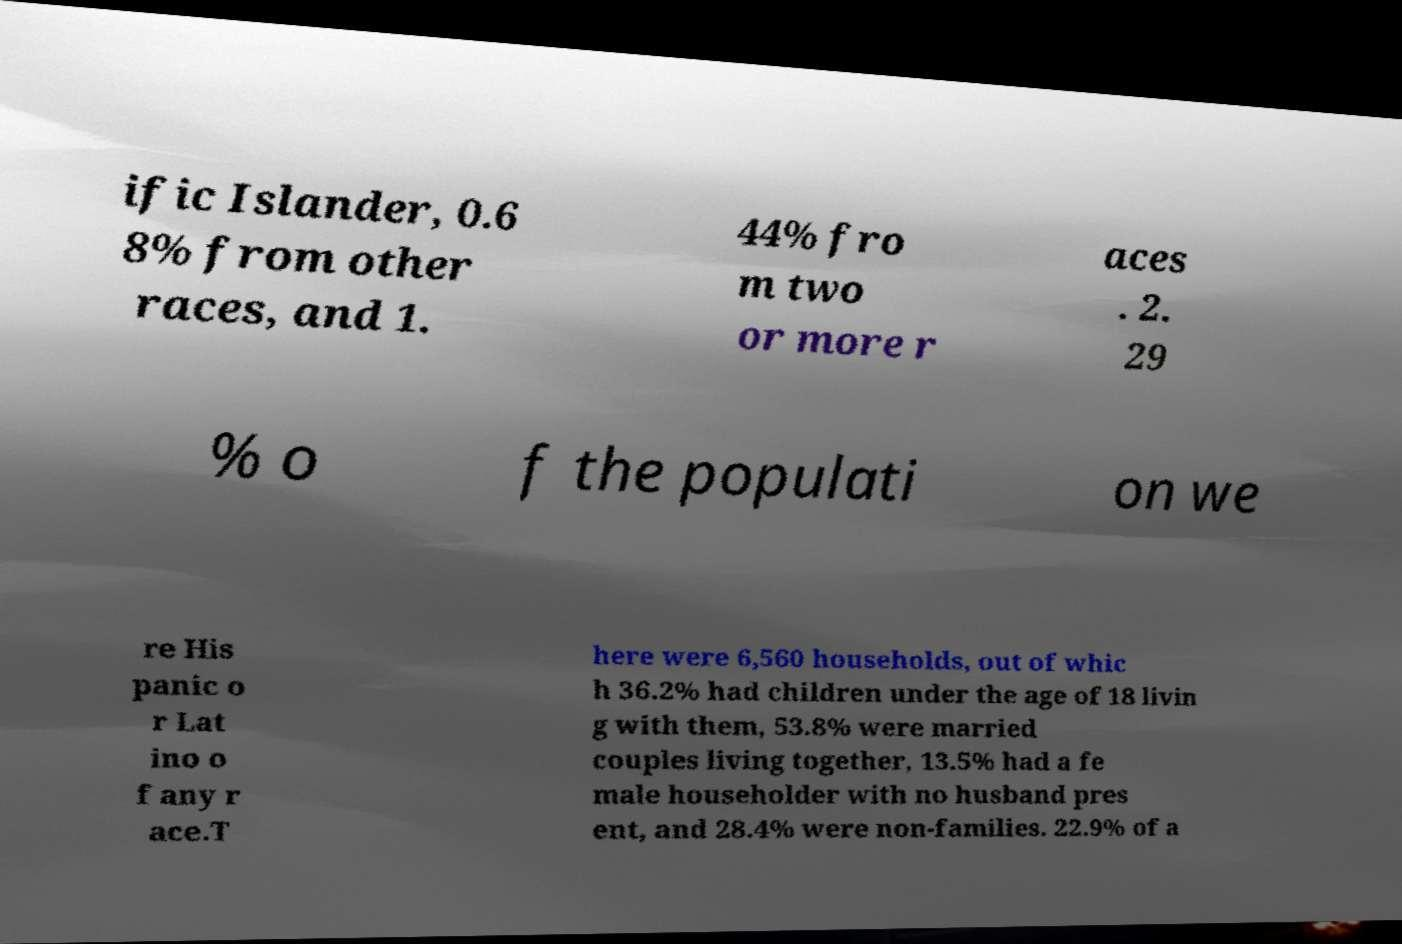Could you assist in decoding the text presented in this image and type it out clearly? ific Islander, 0.6 8% from other races, and 1. 44% fro m two or more r aces . 2. 29 % o f the populati on we re His panic o r Lat ino o f any r ace.T here were 6,560 households, out of whic h 36.2% had children under the age of 18 livin g with them, 53.8% were married couples living together, 13.5% had a fe male householder with no husband pres ent, and 28.4% were non-families. 22.9% of a 